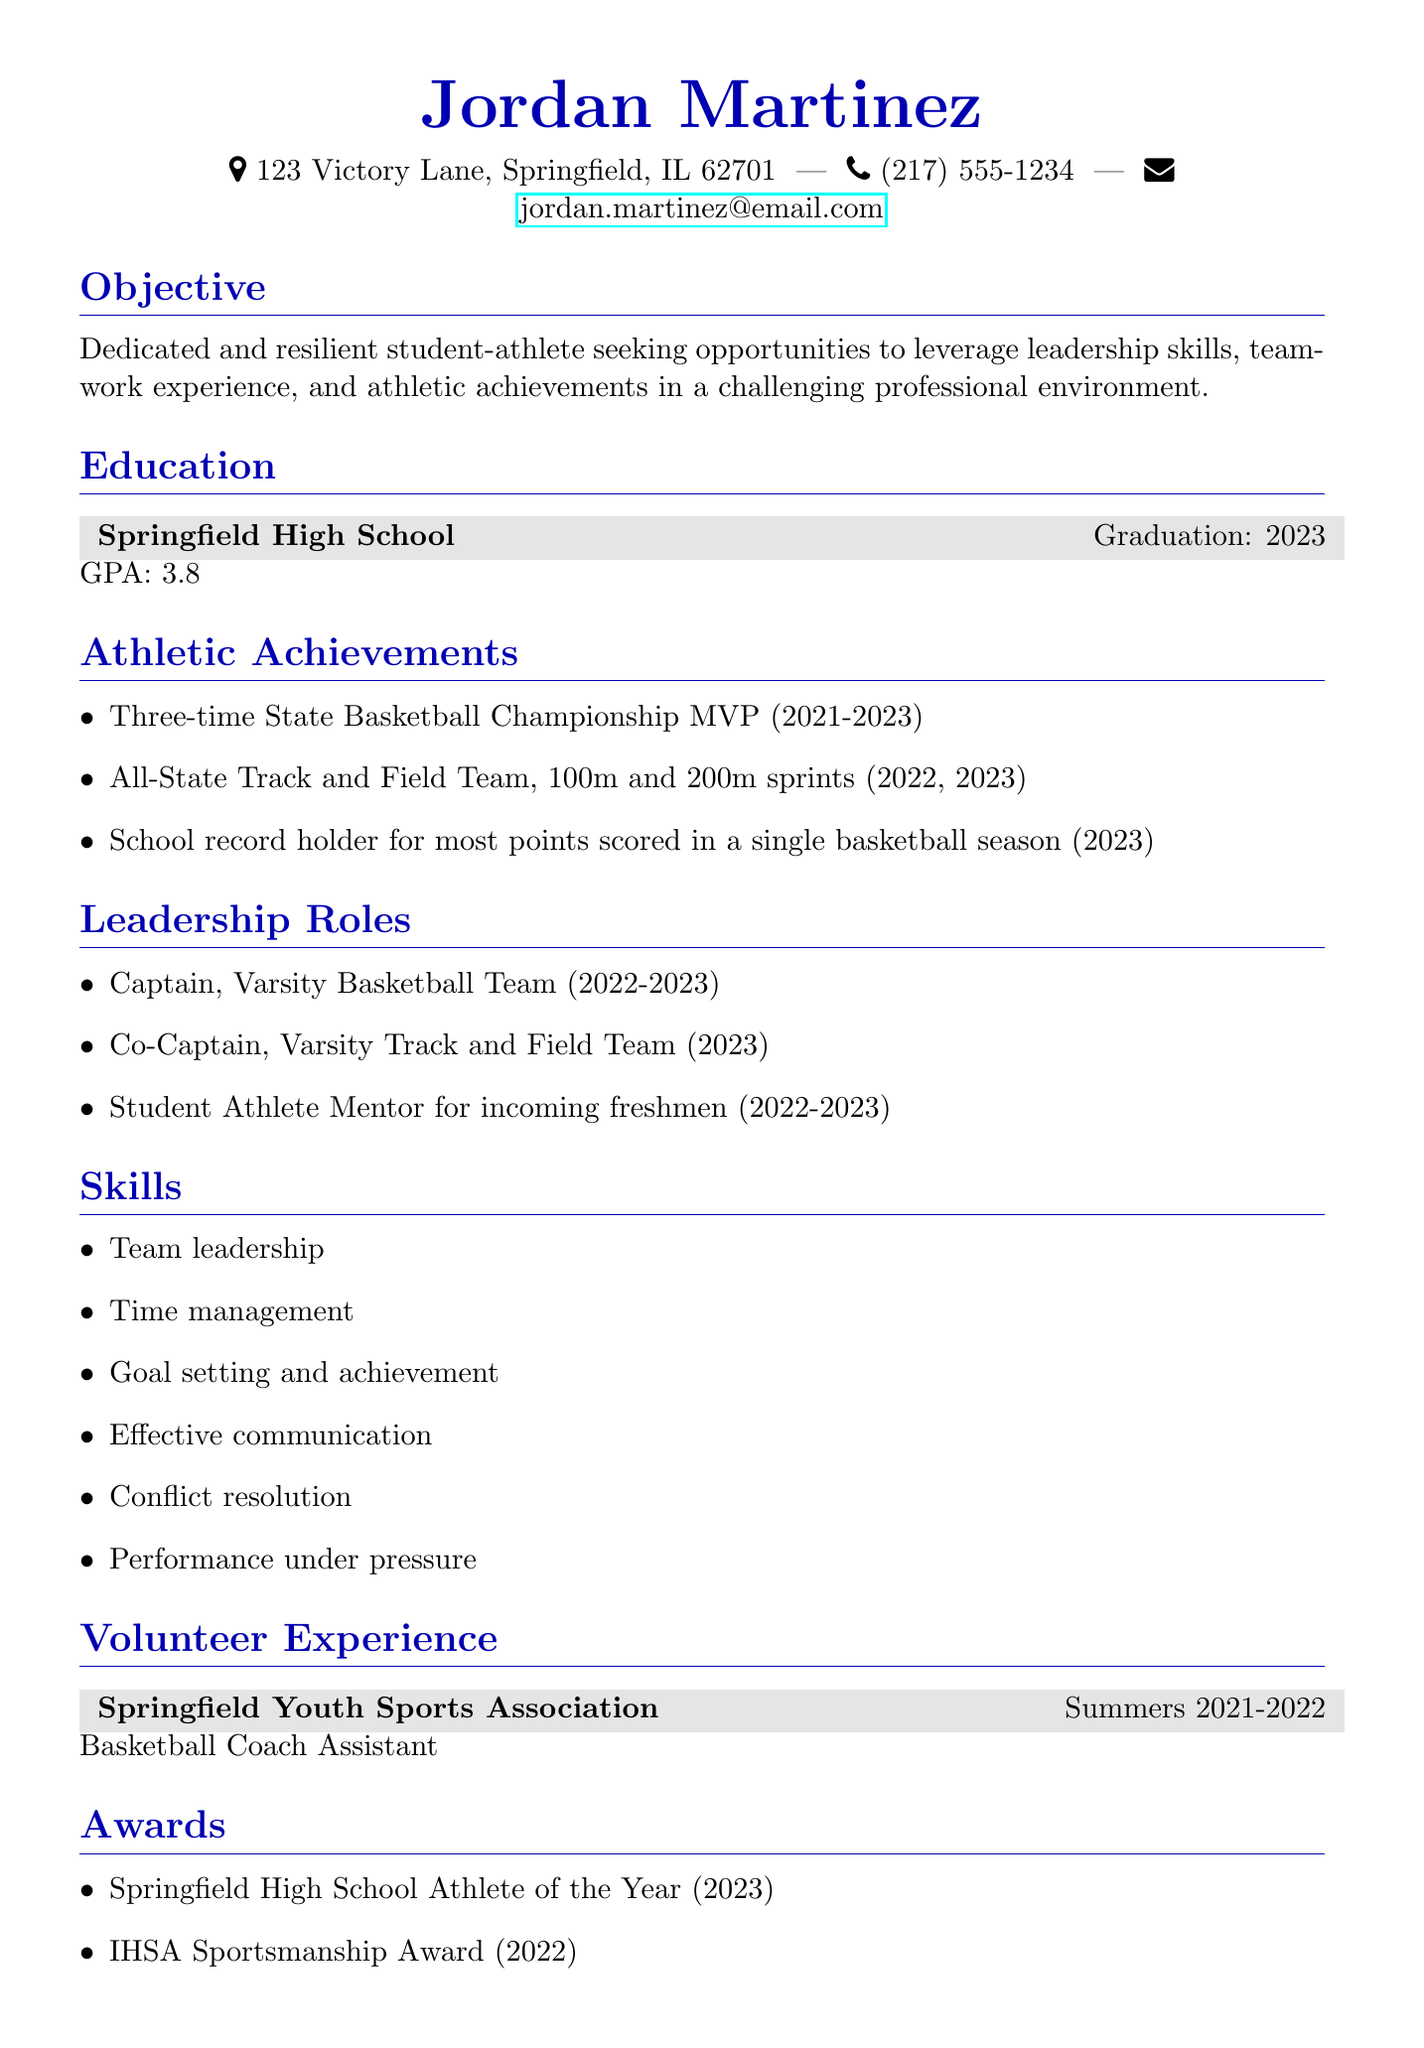What is the name of the individual? The name of the individual is listed at the top of the resume.
Answer: Jordan Martinez What is the graduation year? The graduation year is noted under the education section of the document.
Answer: 2023 How many times was Jordan named State Basketball Championship MVP? This information can be found in the athletic achievements section.
Answer: Three-time What role did Jordan have on the Varsity Basketball Team? The leadership role is specified under the leadership roles section.
Answer: Captain In which organization did Jordan volunteer as a basketball coach assistant? The volunteer experience section identifies the organization.
Answer: Springfield Youth Sports Association What is Jordan's GPA? This detail is provided in the education section of the resume.
Answer: 3.8 Which award did Jordan receive in 2023? The awards section lists the achievements Jordan received.
Answer: Springfield High School Athlete of the Year What skills does Jordan claim to possess? The skills are enumerated in the skills section of the resume.
Answer: Team leadership, Time management, Goal setting and achievement, Effective communication, Conflict resolution, Performance under pressure What was Jordan's role in mentoring incoming freshmen? This information can be found in the leadership roles section.
Answer: Student Athlete Mentor 